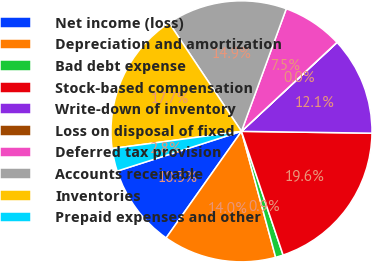Convert chart. <chart><loc_0><loc_0><loc_500><loc_500><pie_chart><fcel>Net income (loss)<fcel>Depreciation and amortization<fcel>Bad debt expense<fcel>Stock-based compensation<fcel>Write-down of inventory<fcel>Loss on disposal of fixed<fcel>Deferred tax provision<fcel>Accounts receivable<fcel>Inventories<fcel>Prepaid expenses and other<nl><fcel>10.28%<fcel>14.01%<fcel>0.95%<fcel>19.61%<fcel>12.15%<fcel>0.02%<fcel>7.48%<fcel>14.94%<fcel>17.74%<fcel>2.82%<nl></chart> 